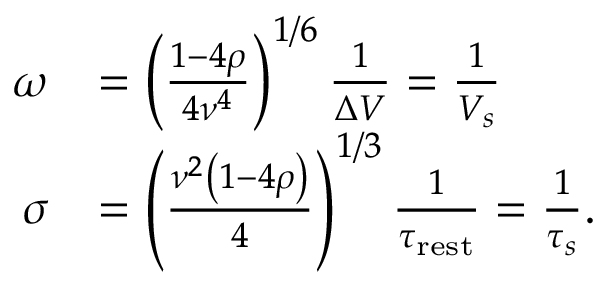<formula> <loc_0><loc_0><loc_500><loc_500>\begin{array} { r l } { \omega } & { = \left ( \frac { 1 - 4 \rho } { 4 \nu ^ { 4 } } \right ) ^ { 1 / 6 } \frac { 1 } { \Delta V } = \frac { 1 } { V _ { s } } } \\ { \sigma } & { = \left ( \frac { \nu ^ { 2 } \left ( 1 - 4 \rho \right ) } { 4 } \right ) ^ { 1 / 3 } \frac { 1 } { \tau _ { r e s t } } = \frac { 1 } { \tau _ { s } } . } \end{array}</formula> 